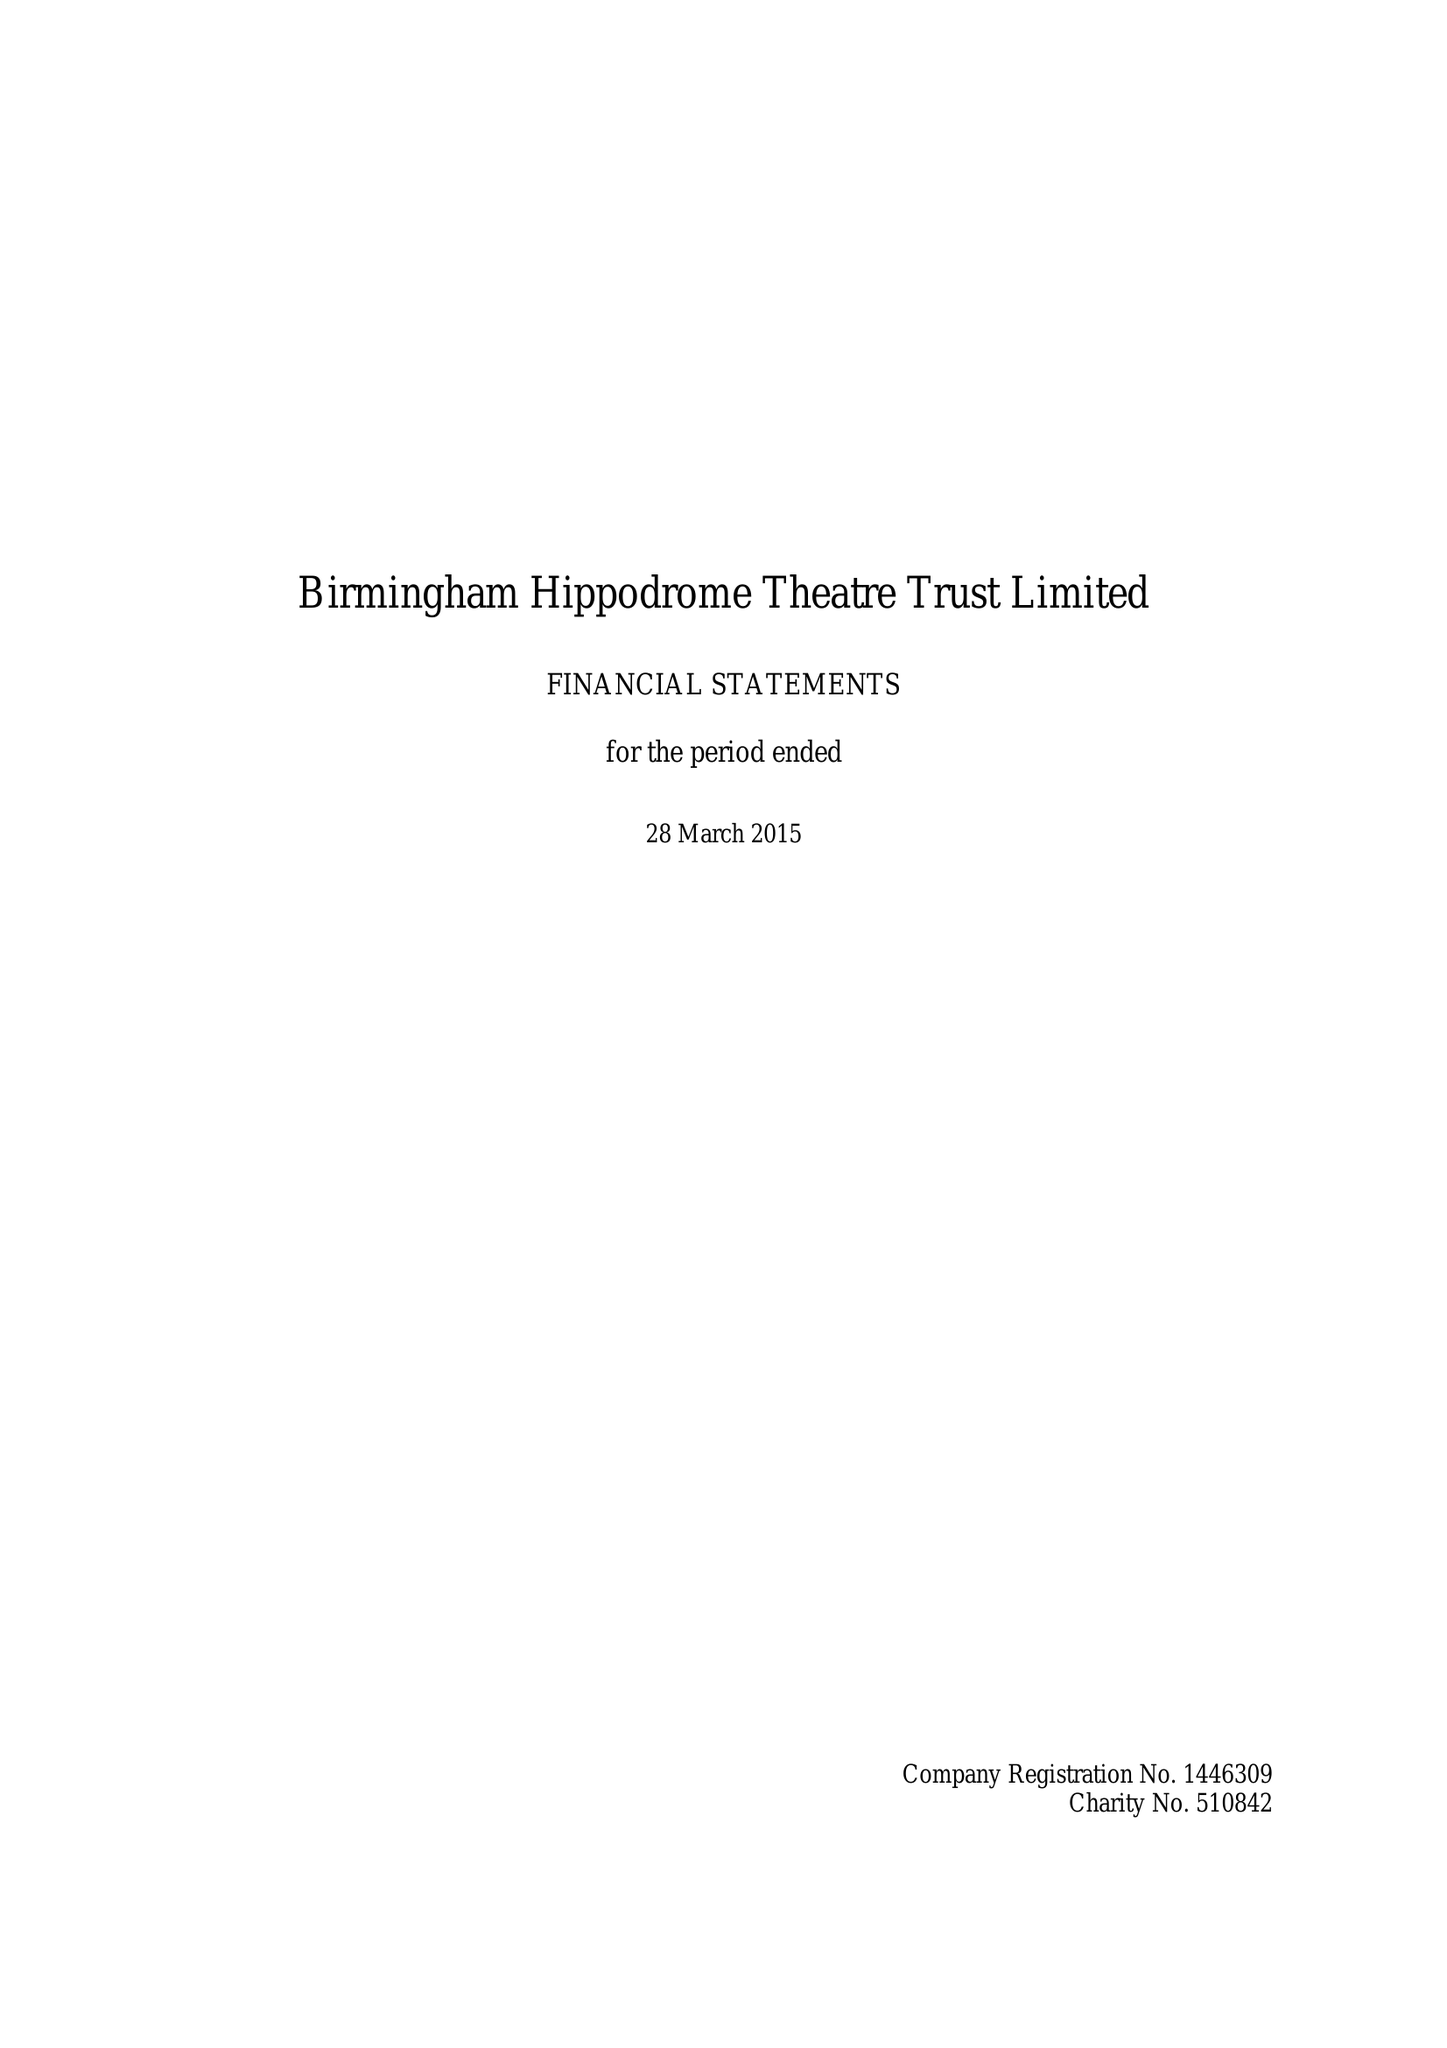What is the value for the address__street_line?
Answer the question using a single word or phrase. HURST STREET 